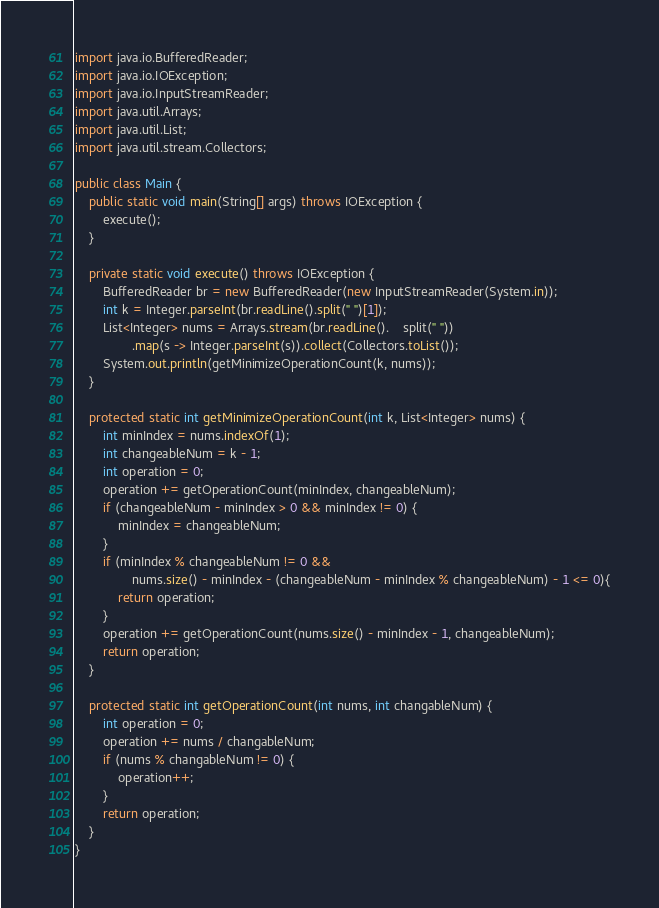Convert code to text. <code><loc_0><loc_0><loc_500><loc_500><_Java_>import java.io.BufferedReader;
import java.io.IOException;
import java.io.InputStreamReader;
import java.util.Arrays;
import java.util.List;
import java.util.stream.Collectors;

public class Main {
    public static void main(String[] args) throws IOException {
        execute();
    }

    private static void execute() throws IOException {
        BufferedReader br = new BufferedReader(new InputStreamReader(System.in));
        int k = Integer.parseInt(br.readLine().split(" ")[1]);
        List<Integer> nums = Arrays.stream(br.readLine().    split(" "))
                .map(s -> Integer.parseInt(s)).collect(Collectors.toList());
        System.out.println(getMinimizeOperationCount(k, nums));
    }

    protected static int getMinimizeOperationCount(int k, List<Integer> nums) {
        int minIndex = nums.indexOf(1);
        int changeableNum = k - 1;
        int operation = 0;
        operation += getOperationCount(minIndex, changeableNum);
        if (changeableNum - minIndex > 0 && minIndex != 0) {
            minIndex = changeableNum;
        }
        if (minIndex % changeableNum != 0 &&
                nums.size() - minIndex - (changeableNum - minIndex % changeableNum) - 1 <= 0){
            return operation;
        }
        operation += getOperationCount(nums.size() - minIndex - 1, changeableNum);
        return operation;
    }

    protected static int getOperationCount(int nums, int changableNum) {
        int operation = 0;
        operation += nums / changableNum;
        if (nums % changableNum != 0) {
            operation++;
        }
        return operation;
    }
}</code> 